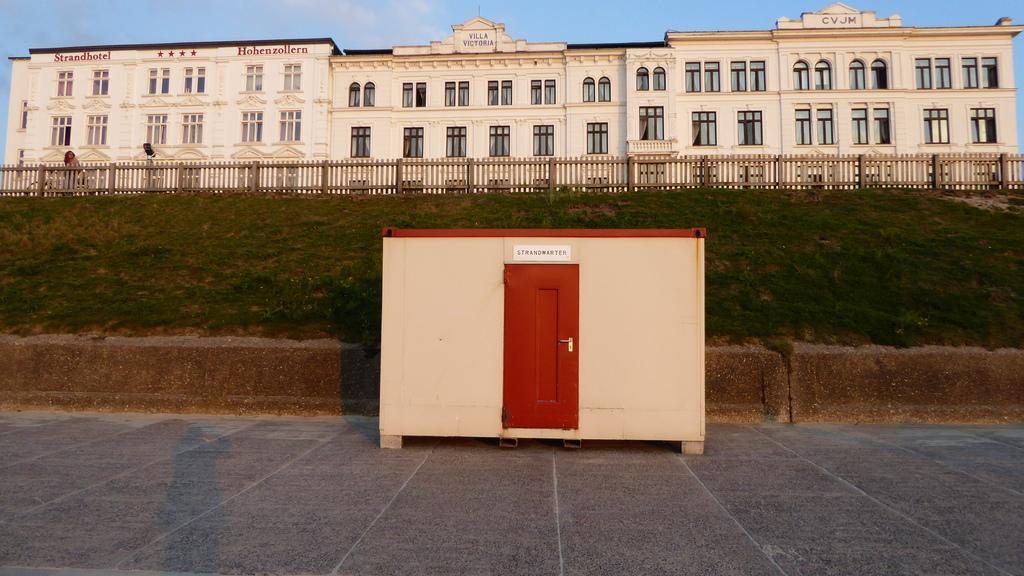Could you give a brief overview of what you see in this image? We can see shelter on the surface and door, behind this shelter we can see wall and grass. In the background we can see fence, building, windows and sky. 